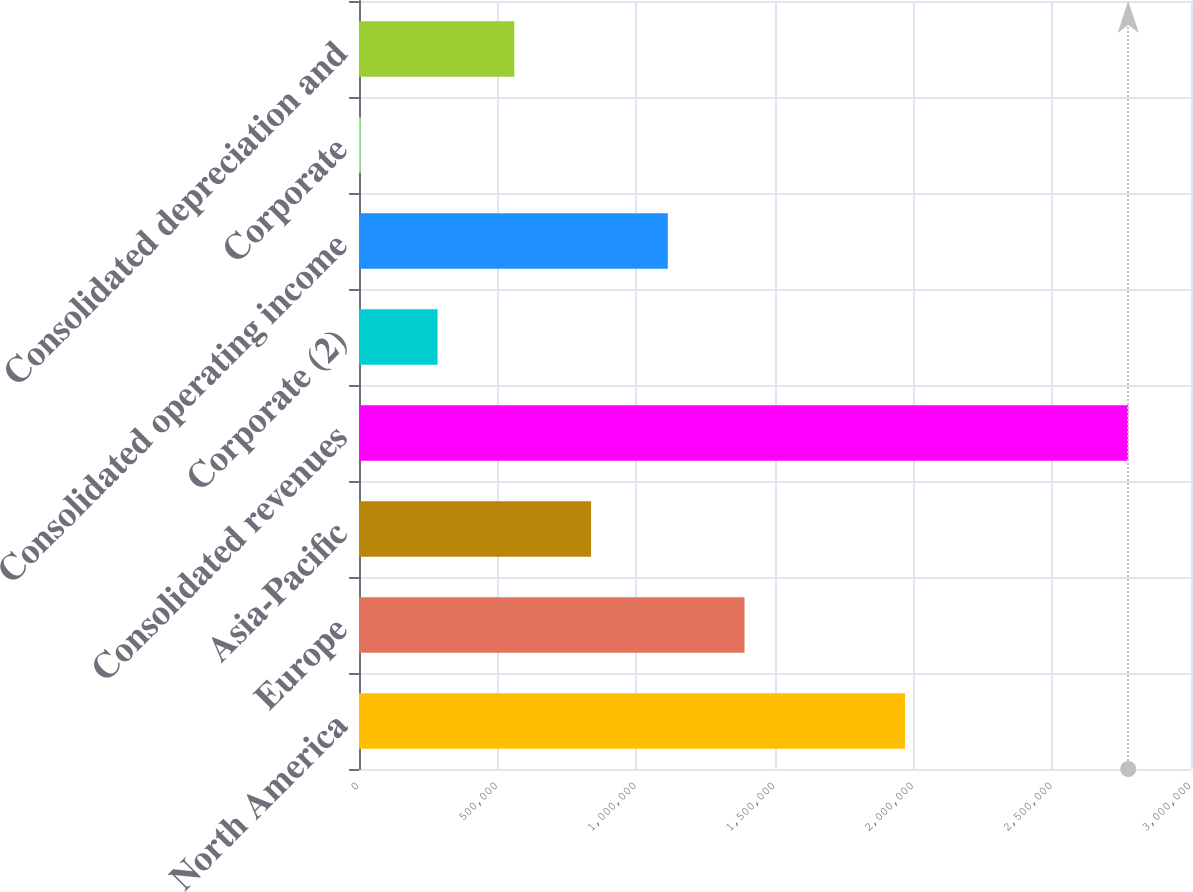<chart> <loc_0><loc_0><loc_500><loc_500><bar_chart><fcel>North America<fcel>Europe<fcel>Asia-Pacific<fcel>Consolidated revenues<fcel>Corporate (2)<fcel>Consolidated operating income<fcel>Corporate<fcel>Consolidated depreciation and<nl><fcel>1.96889e+06<fcel>1.39014e+06<fcel>836715<fcel>2.77372e+06<fcel>283286<fcel>1.11343e+06<fcel>6571<fcel>560000<nl></chart> 